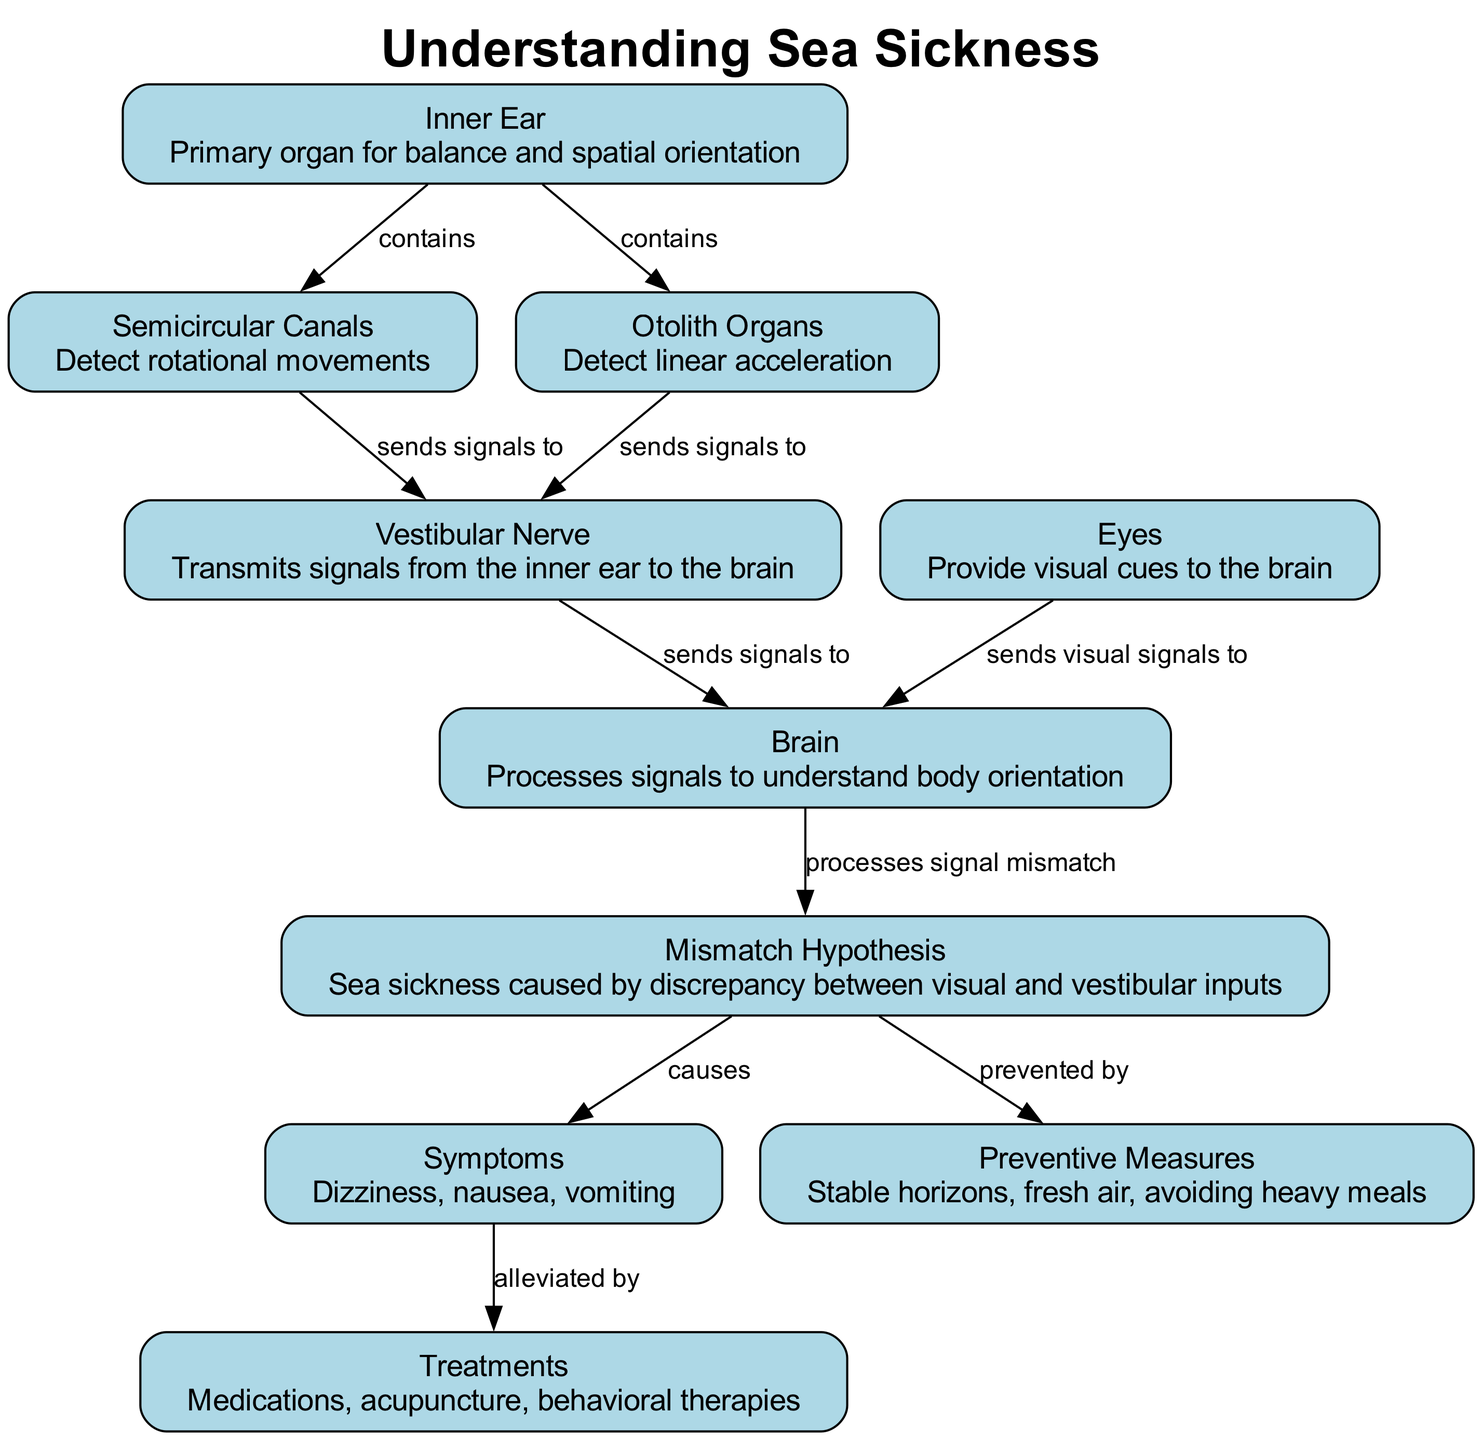What is the primary organ for balance? The diagram identifies the "Inner Ear" as the primary organ responsible for balance and spatial orientation.
Answer: Inner Ear How many semicircular canals are shown? The diagram highlights "Semicircular Canals," which refers to three canals in the vestibular system.
Answer: Three What does the vestibular nerve do? The "Vestibular Nerve" is shown to transmit signals from the inner ear to the brain, indicating its role in communication of balance information.
Answer: Transmits signals from the inner ear to the brain What causes sea sickness according to the diagram? The "Mismatch Hypothesis" explains that sea sickness is caused by a discrepancy between visual and vestibular inputs, leading to conflicting signals interpreted by the brain.
Answer: Discrepancy between visual and vestibular inputs What are the symptoms of sea sickness listed in the diagram? The diagram lists symptoms such as dizziness, nausea, and vomiting under the "Symptoms" section, which reflects the common effects of sea sickness.
Answer: Dizziness, nausea, vomiting How can sea sickness be prevented? The diagram points to "Preventive Measures," which include concepts like maintaining stable horizons and consuming light meals to avert the onset of sea sickness.
Answer: Stable horizons, fresh air, avoiding heavy meals What is processed to understand body orientation? The "Brain" is responsible for processing signals received from the vestibular nerve and visual signals to determine body orientation and balance.
Answer: Brain Which node shows alleviation methods for symptoms? The "Treatments" node indicates various ways to alleviate the symptoms of sea sickness, such as medications and behavioral therapies.
Answer: Treatments 